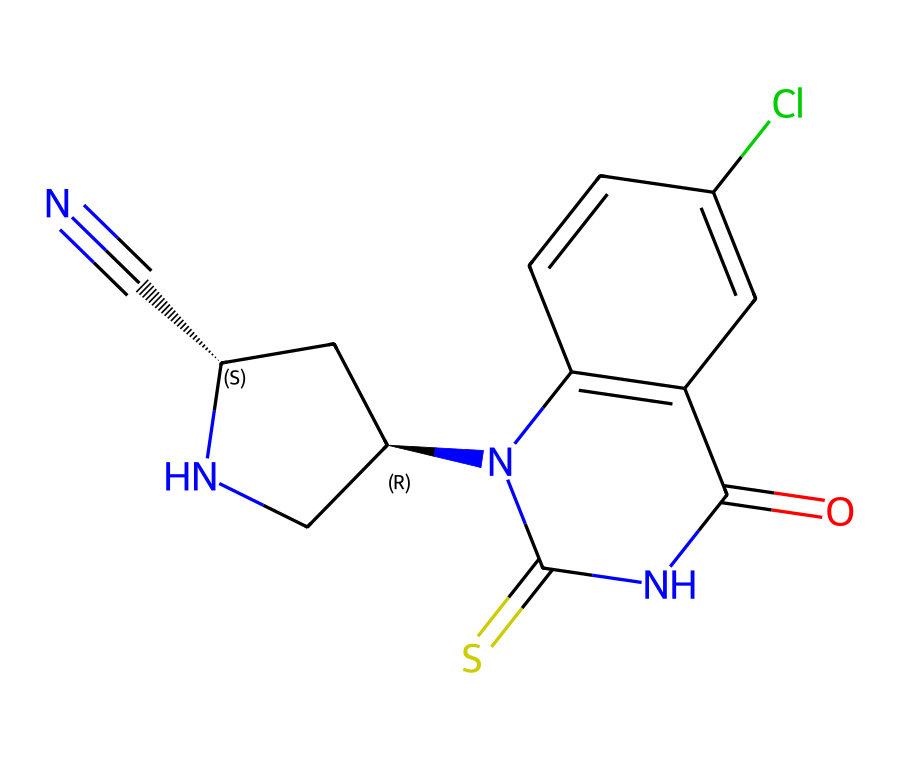What is the main functional group present in this chemical? Observing the structure, we notice a carbonyl group (C=O) connected to a nitrogen atom, which is characteristic of amides or thioamides. Given the context of neonicotinoids, it is a thioamide functional group.
Answer: thioamide How many nitrogen atoms are present in the compound? By inspecting the SMILES representation, we can identify three nitrogen atoms: one in the thioamide group, and two in the cyclic structure.
Answer: three What is the role of chlorine in this chemical? The chlorine atom, located in the aromatic ring, contributes to the lipophilicity of the compound, enhancing its efficacy as an insecticide.
Answer: lipophilicity Which part of the chemical structure indicates its systemic nature? The presence of the carbon-nitrogen bond and the overall structure allows for absorption and translocation within the plant, characteristic of systemic pesticides.
Answer: carbon-nitrogen bond What type of action does this neonicotinoid primarily exhibit against pests? Neonicotinoids primarily act as nicotinic acetylcholine receptor agonists, disrupting synaptic transmission in insects.
Answer: agonist 